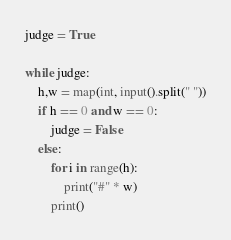<code> <loc_0><loc_0><loc_500><loc_500><_Python_>judge = True

while judge:
    h,w = map(int, input().split(" "))
    if h == 0 and w == 0:
        judge = False
    else:
        for i in range(h):
            print("#" * w)
        print()</code> 